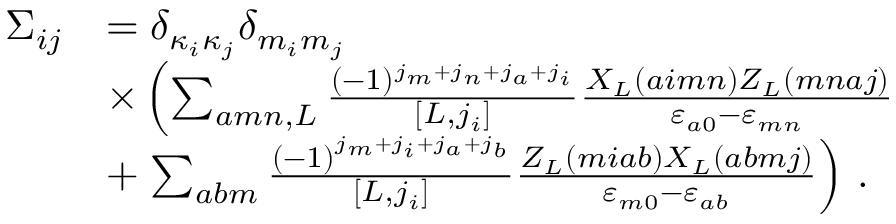Convert formula to latex. <formula><loc_0><loc_0><loc_500><loc_500>\begin{array} { r l } { \Sigma _ { i j } } & { = \delta _ { \kappa _ { i } \kappa _ { j } } \delta _ { m _ { i } m _ { j } } } \\ & { \times \left ( \sum _ { a m n , L } \frac { ( - 1 ) ^ { j _ { m } + j _ { n } + j _ { a } + j _ { i } } } { [ L , j _ { i } ] } \frac { X _ { L } ( a i m n ) Z _ { L } ( m n a j ) } { \varepsilon _ { a 0 } - \varepsilon _ { m n } } } \\ & { + \sum _ { a b m } \frac { \left ( - 1 \right ) ^ { j _ { m } + j _ { i } + j _ { a } + j _ { b } } } { \left [ L , j _ { i } \right ] } \frac { Z _ { L } \left ( m i a b \right ) X _ { L } \left ( a b m j \right ) } { \varepsilon _ { m 0 } - \varepsilon _ { a b } } \right ) \, . } \end{array}</formula> 